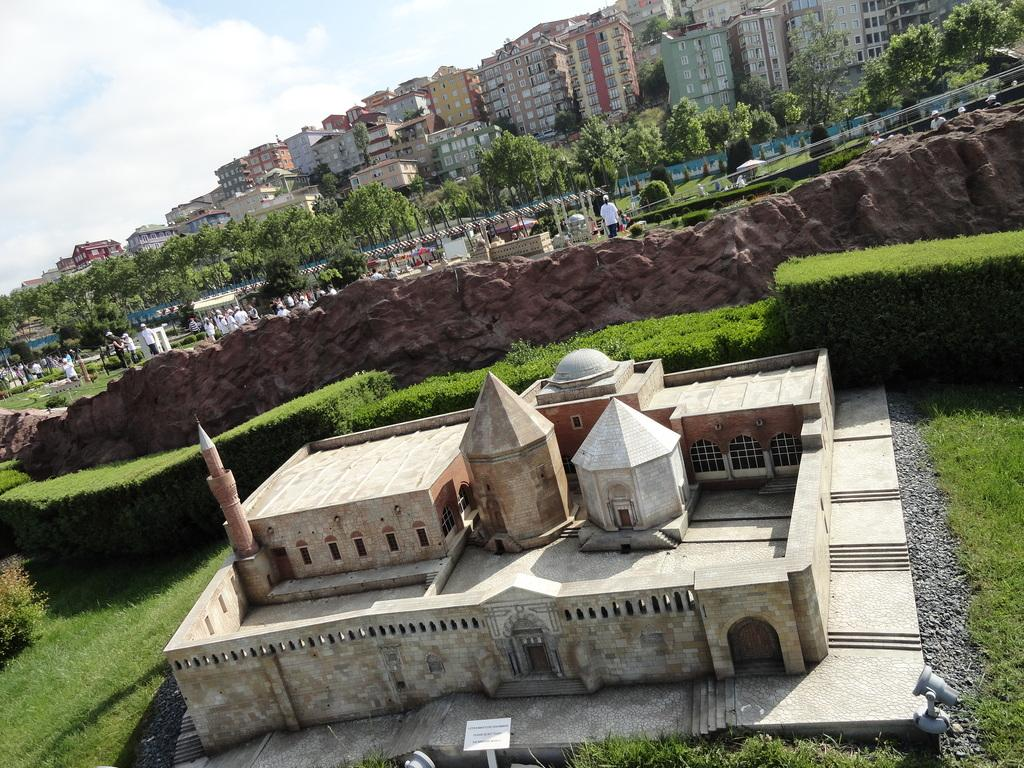What type of structures are present in the image? There are buildings with windows in the image. What type of vegetation can be seen in the image? There are plants, trees, and grass in the image. Who or what is present in the image? There are people and rocks in the image. What is visible in the background of the image? The sky is visible in the background of the image. What type of mailbox can be seen in the image? There is no mailbox present in the image. What are the people in the image reading? There is no indication of reading in the image; the people are not holding any books or papers. 